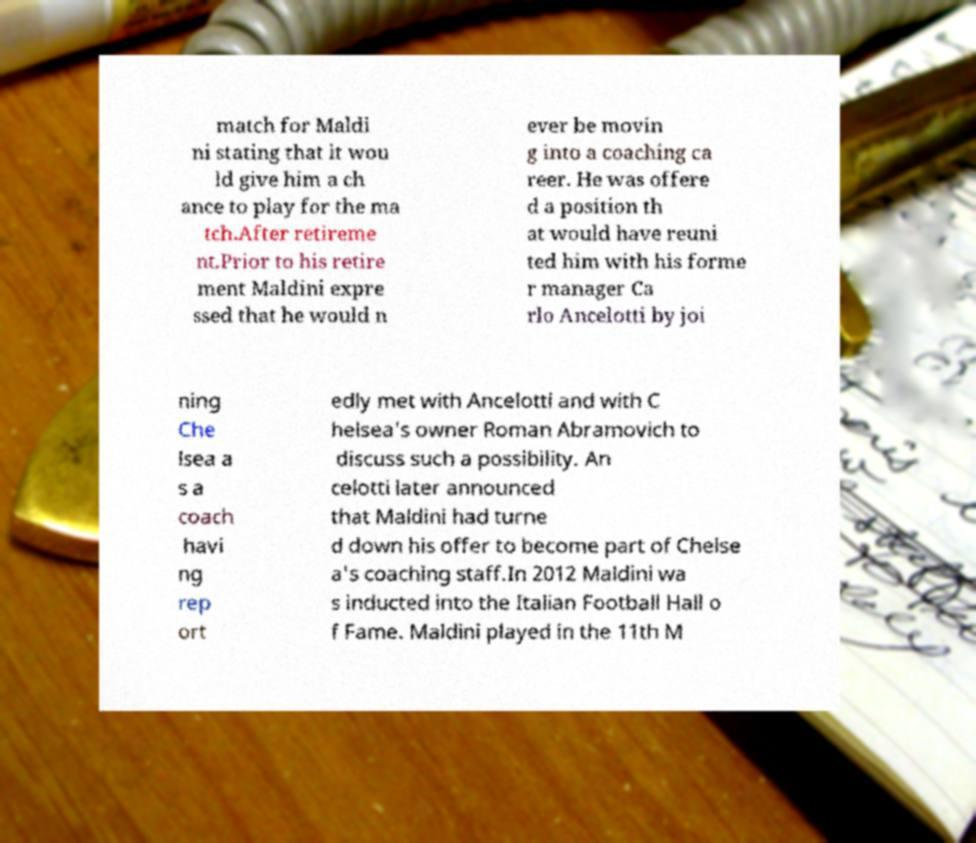Please identify and transcribe the text found in this image. match for Maldi ni stating that it wou ld give him a ch ance to play for the ma tch.After retireme nt.Prior to his retire ment Maldini expre ssed that he would n ever be movin g into a coaching ca reer. He was offere d a position th at would have reuni ted him with his forme r manager Ca rlo Ancelotti by joi ning Che lsea a s a coach havi ng rep ort edly met with Ancelotti and with C helsea's owner Roman Abramovich to discuss such a possibility. An celotti later announced that Maldini had turne d down his offer to become part of Chelse a's coaching staff.In 2012 Maldini wa s inducted into the Italian Football Hall o f Fame. Maldini played in the 11th M 